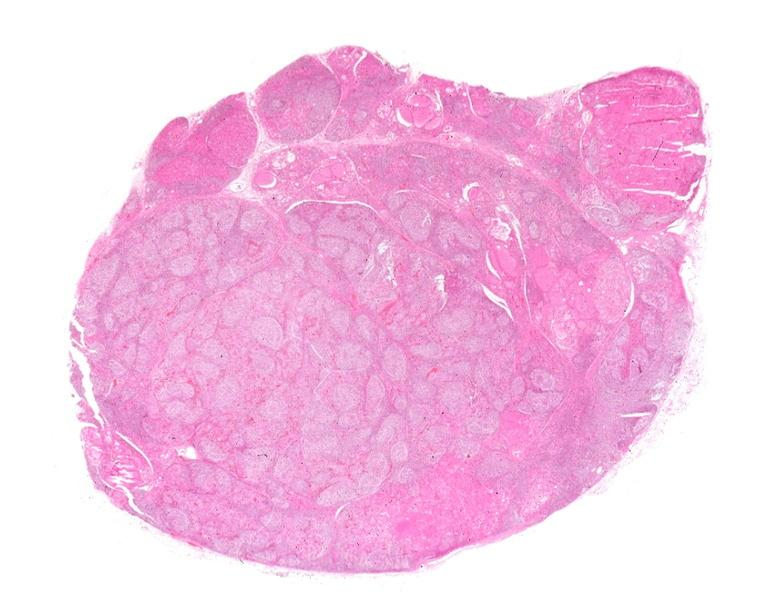what does this image show?
Answer the question using a single word or phrase. Hashimoto 's thyroiditis 